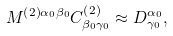Convert formula to latex. <formula><loc_0><loc_0><loc_500><loc_500>M ^ { \left ( 2 \right ) \alpha _ { 0 } \beta _ { 0 } } C _ { \beta _ { 0 } \gamma _ { 0 } } ^ { \left ( 2 \right ) } \approx D _ { \gamma _ { 0 } } ^ { \alpha _ { 0 } } ,</formula> 